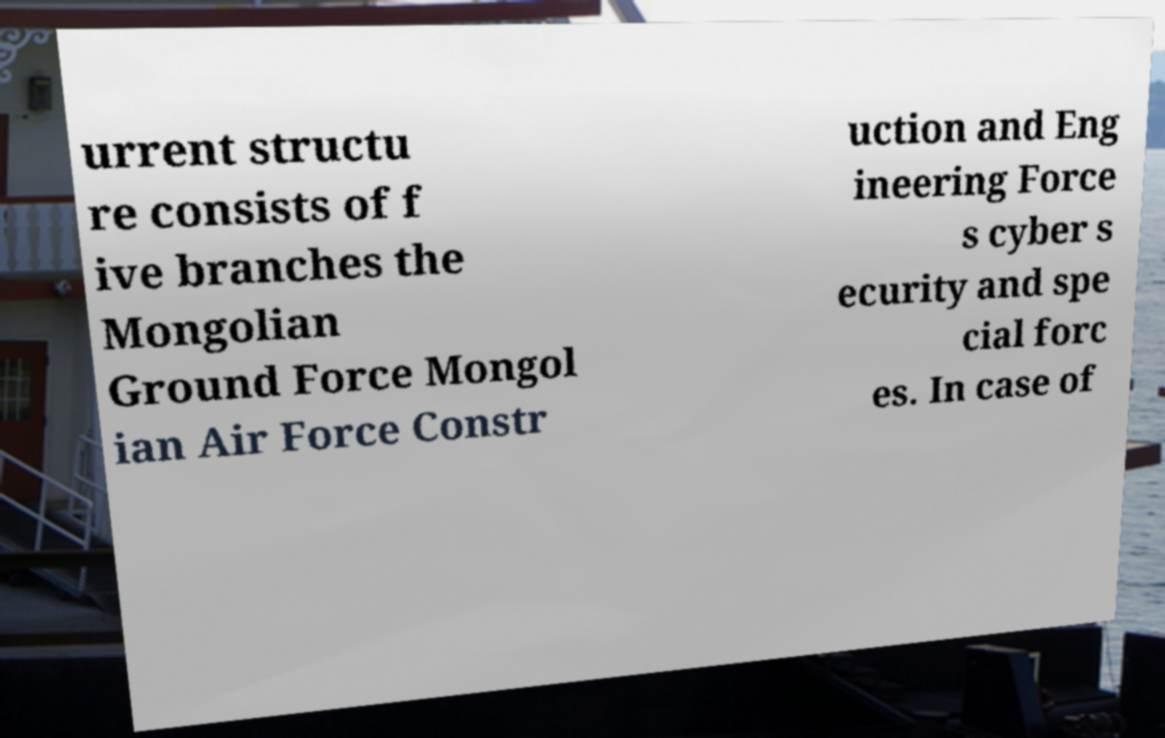What messages or text are displayed in this image? I need them in a readable, typed format. urrent structu re consists of f ive branches the Mongolian Ground Force Mongol ian Air Force Constr uction and Eng ineering Force s cyber s ecurity and spe cial forc es. In case of 